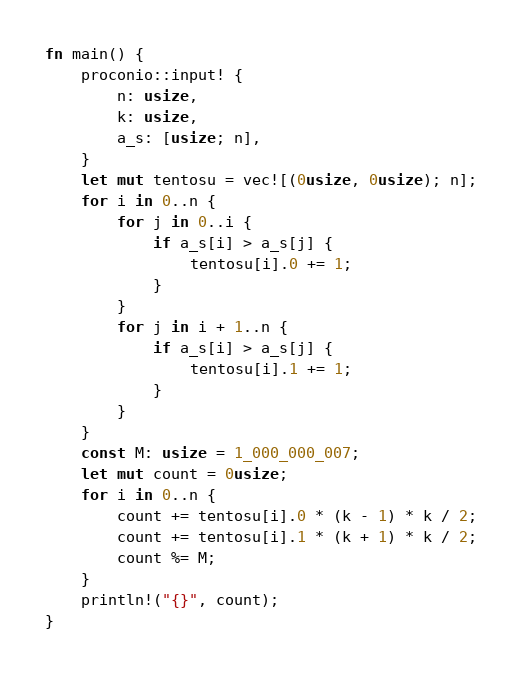<code> <loc_0><loc_0><loc_500><loc_500><_Rust_>fn main() {
    proconio::input! {
        n: usize,
        k: usize,
        a_s: [usize; n],
    }
    let mut tentosu = vec![(0usize, 0usize); n];
    for i in 0..n {
        for j in 0..i {
            if a_s[i] > a_s[j] {
                tentosu[i].0 += 1;
            }
        }
        for j in i + 1..n {
            if a_s[i] > a_s[j] {
                tentosu[i].1 += 1;
            }
        }
    }
    const M: usize = 1_000_000_007;
    let mut count = 0usize;
    for i in 0..n {
        count += tentosu[i].0 * (k - 1) * k / 2;
        count += tentosu[i].1 * (k + 1) * k / 2;
        count %= M;
    }
    println!("{}", count);
}
</code> 